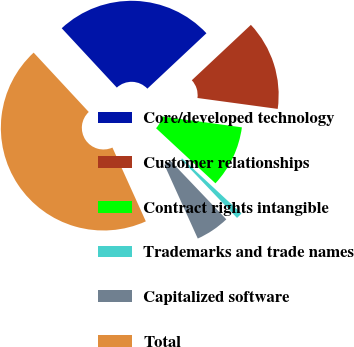<chart> <loc_0><loc_0><loc_500><loc_500><pie_chart><fcel>Core/developed technology<fcel>Customer relationships<fcel>Contract rights intangible<fcel>Trademarks and trade names<fcel>Capitalized software<fcel>Total<nl><fcel>24.92%<fcel>14.14%<fcel>9.75%<fcel>0.97%<fcel>5.36%<fcel>44.85%<nl></chart> 